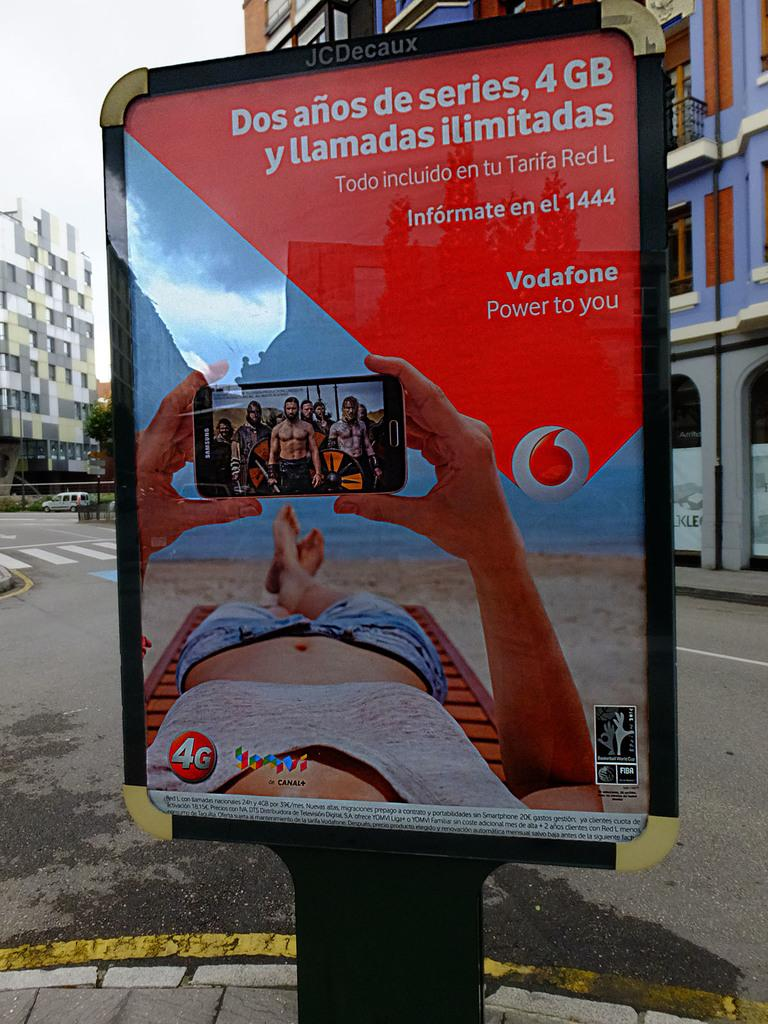<image>
Give a short and clear explanation of the subsequent image. Vodafone has placed a street ad in Spanish advertising a two year deal of unlimited calls and 4G service. 